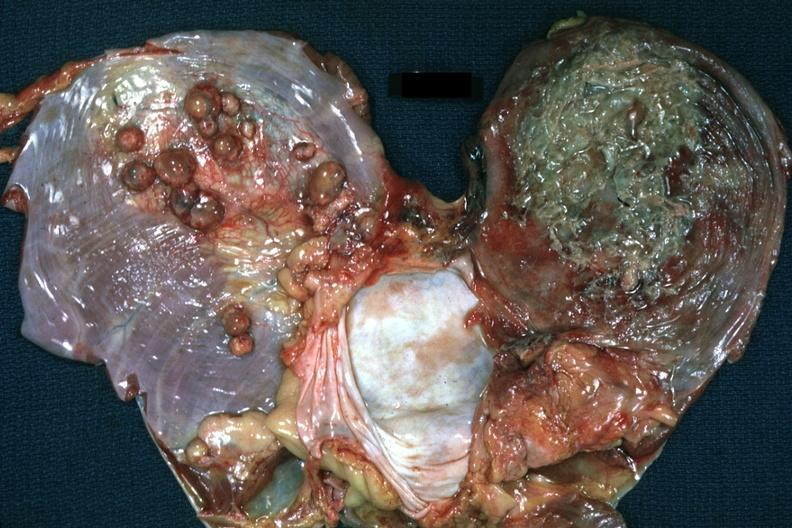what does this image leave?
Answer the question using a single word or phrase. Both leaves of diaphragm one covered by purulent exudate and the other with multiple tumor nodules 